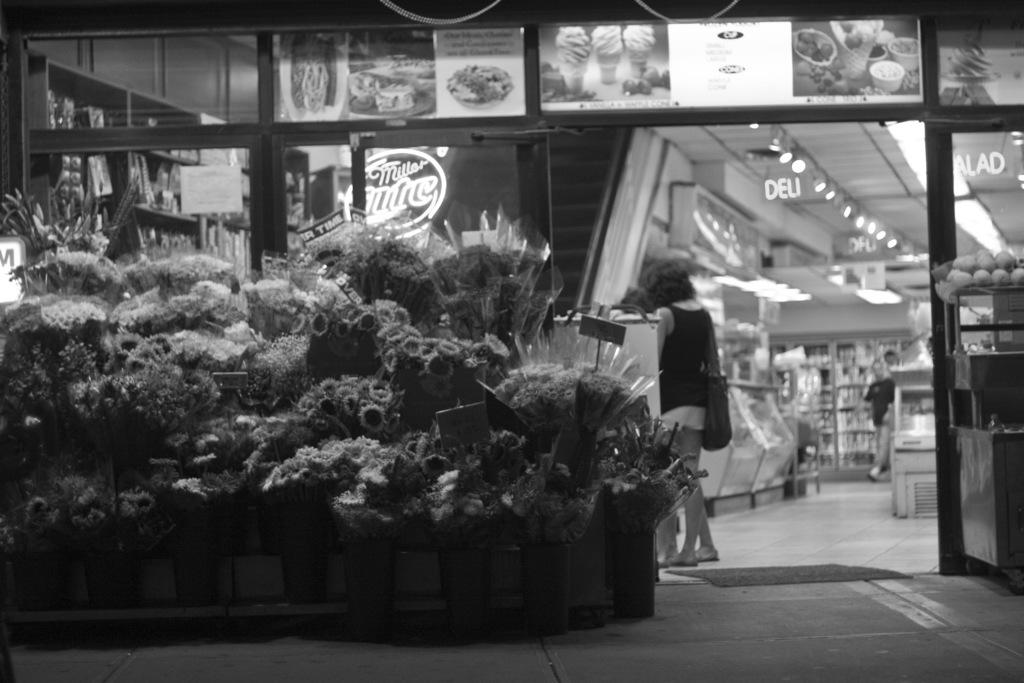What type of floral arrangements can be seen in the image? There are flower bouquets in the image. Can you describe the people in the image? There are people in the image, but their specific actions or appearances are not mentioned in the provided facts. What can be seen in the background of the image? In the background of the image, there are posts and lights. Are there any other objects visible in the background of the image? Yes, there are additional objects visible in the background of the image, but their specific nature is not mentioned in the provided facts. Reasoning: Let' Let's think step by step in order to produce the conversation. We start by identifying the main subject in the image, which is the flower bouquets. Then, we mention the presence of people in the image, but we avoid making any assumptions about their actions or appearances. Next, we describe the background of the image, focusing on the posts and lights. Finally, we acknowledge the presence of additional objects in the background, but we do not attempt to identify them specifically. Absurd Question/Answer: How many geese are flying over the flower bouquets in the image? There are no geese present in the image; it features flower bouquets and people with a background of posts, lights, and additional objects. 